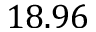<formula> <loc_0><loc_0><loc_500><loc_500>1 8 . 9 6</formula> 